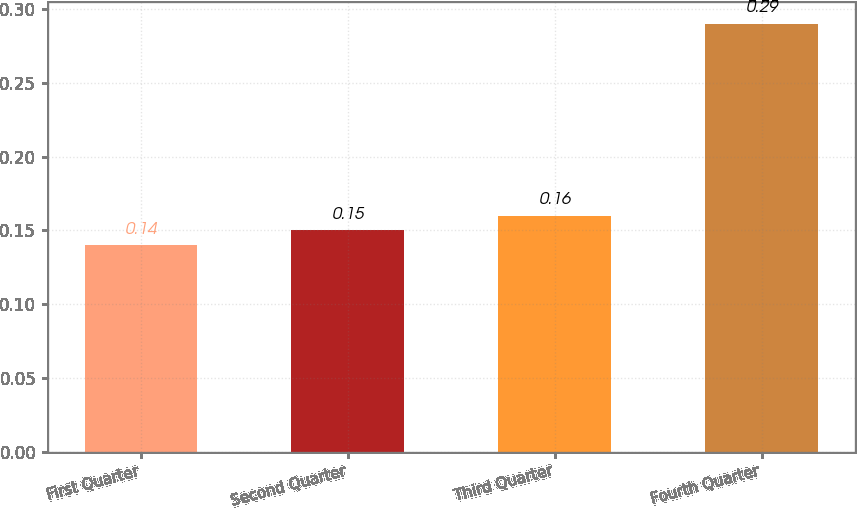<chart> <loc_0><loc_0><loc_500><loc_500><bar_chart><fcel>First Quarter<fcel>Second Quarter<fcel>Third Quarter<fcel>Fourth Quarter<nl><fcel>0.14<fcel>0.15<fcel>0.16<fcel>0.29<nl></chart> 